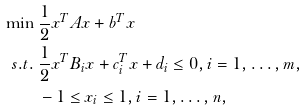Convert formula to latex. <formula><loc_0><loc_0><loc_500><loc_500>\min & \ \frac { 1 } { 2 } x ^ { T } A x + b ^ { T } x \\ s . t . & \ \frac { 1 } { 2 } x ^ { T } B _ { i } x + c _ { i } ^ { T } x + d _ { i } \leq 0 , i = 1 , \dots , m , \\ & \ - 1 \leq x _ { i } \leq 1 , i = 1 , \dots , n ,</formula> 